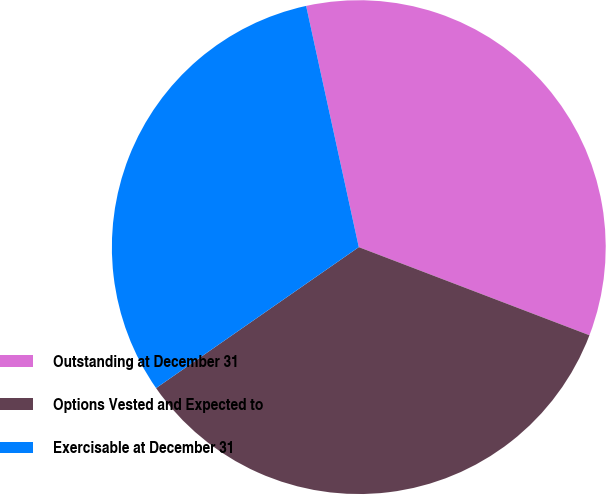Convert chart. <chart><loc_0><loc_0><loc_500><loc_500><pie_chart><fcel>Outstanding at December 31<fcel>Options Vested and Expected to<fcel>Exercisable at December 31<nl><fcel>34.23%<fcel>34.52%<fcel>31.25%<nl></chart> 